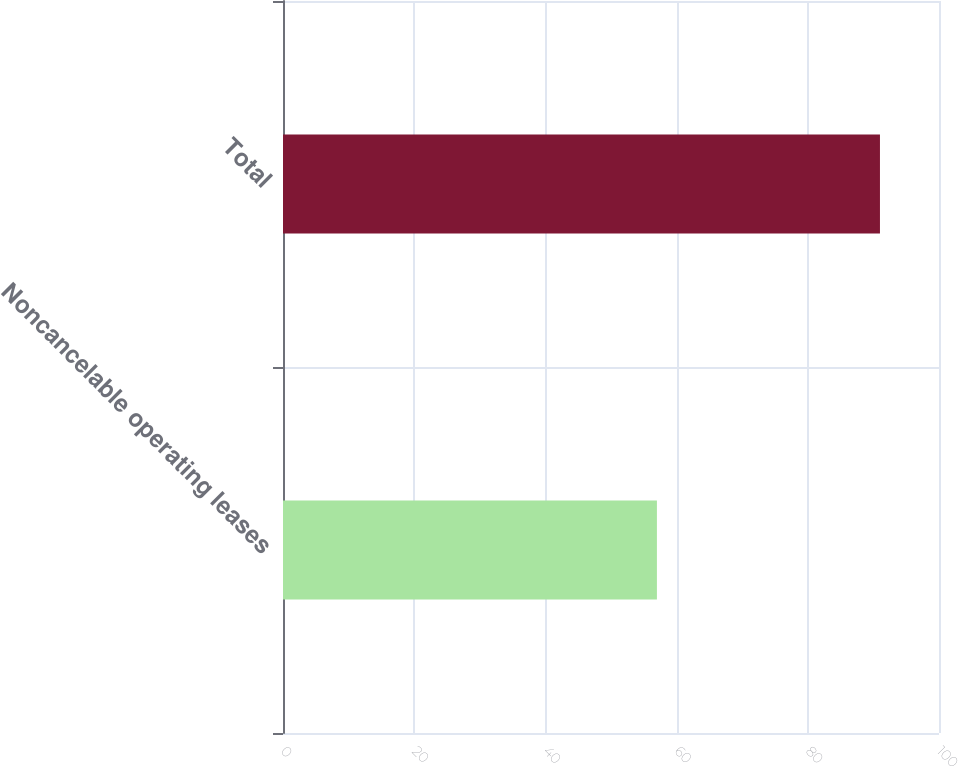Convert chart. <chart><loc_0><loc_0><loc_500><loc_500><bar_chart><fcel>Noncancelable operating leases<fcel>Total<nl><fcel>57<fcel>91<nl></chart> 